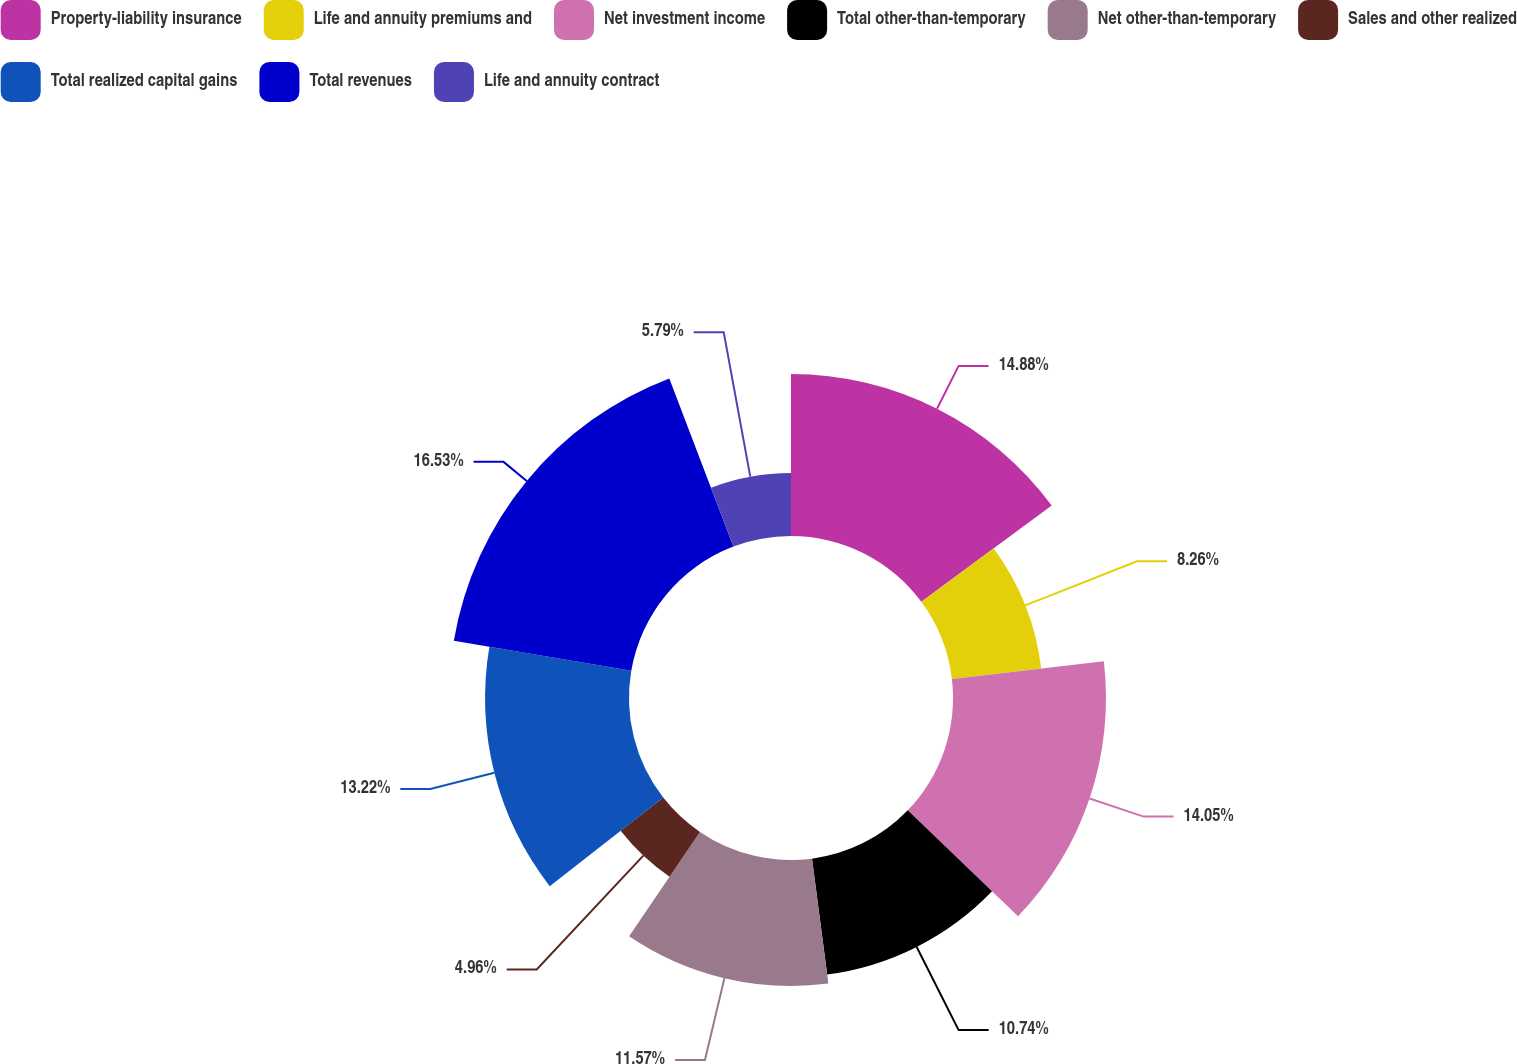<chart> <loc_0><loc_0><loc_500><loc_500><pie_chart><fcel>Property-liability insurance<fcel>Life and annuity premiums and<fcel>Net investment income<fcel>Total other-than-temporary<fcel>Net other-than-temporary<fcel>Sales and other realized<fcel>Total realized capital gains<fcel>Total revenues<fcel>Life and annuity contract<nl><fcel>14.88%<fcel>8.26%<fcel>14.05%<fcel>10.74%<fcel>11.57%<fcel>4.96%<fcel>13.22%<fcel>16.53%<fcel>5.79%<nl></chart> 